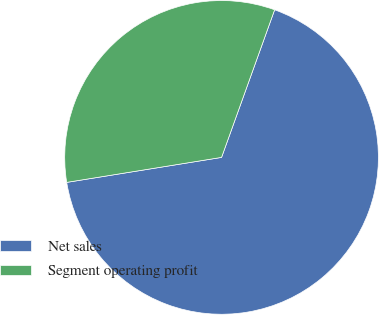Convert chart to OTSL. <chart><loc_0><loc_0><loc_500><loc_500><pie_chart><fcel>Net sales<fcel>Segment operating profit<nl><fcel>66.96%<fcel>33.04%<nl></chart> 